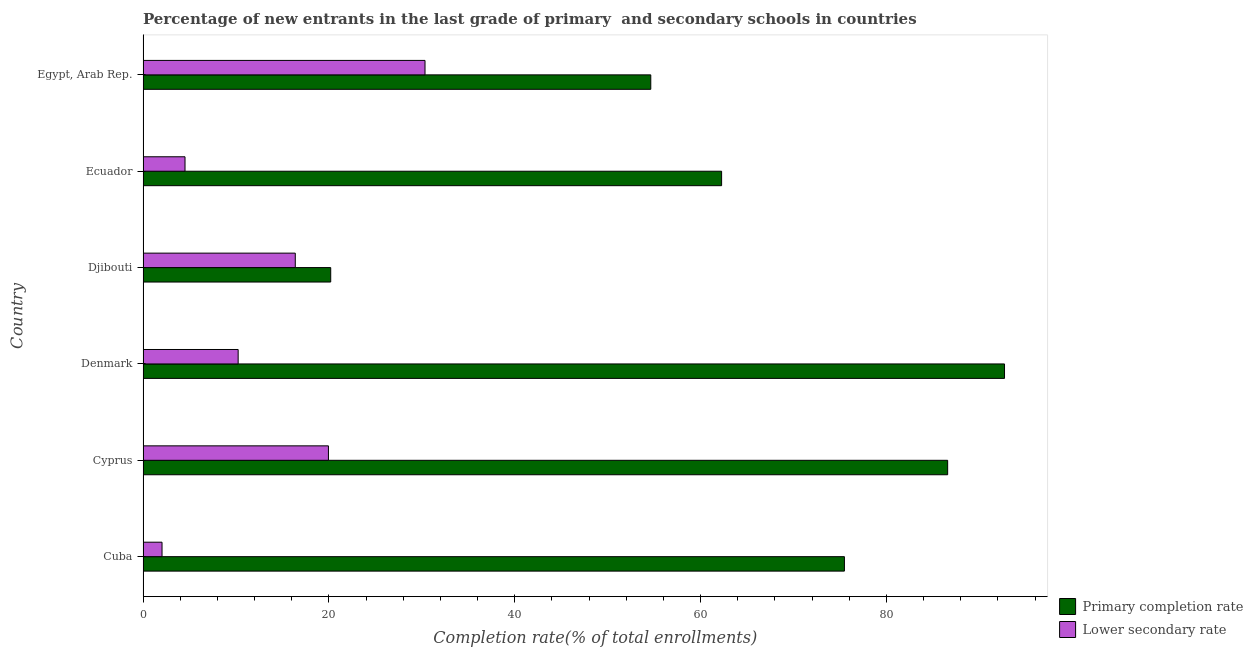How many different coloured bars are there?
Provide a succinct answer. 2. How many bars are there on the 5th tick from the top?
Keep it short and to the point. 2. What is the label of the 3rd group of bars from the top?
Offer a terse response. Djibouti. What is the completion rate in secondary schools in Egypt, Arab Rep.?
Provide a succinct answer. 30.35. Across all countries, what is the maximum completion rate in secondary schools?
Offer a terse response. 30.35. Across all countries, what is the minimum completion rate in primary schools?
Offer a very short reply. 20.2. In which country was the completion rate in primary schools minimum?
Ensure brevity in your answer.  Djibouti. What is the total completion rate in secondary schools in the graph?
Ensure brevity in your answer.  83.47. What is the difference between the completion rate in primary schools in Denmark and that in Egypt, Arab Rep.?
Give a very brief answer. 38.07. What is the difference between the completion rate in primary schools in Egypt, Arab Rep. and the completion rate in secondary schools in Cuba?
Provide a short and direct response. 52.6. What is the average completion rate in primary schools per country?
Offer a very short reply. 65.32. What is the difference between the completion rate in primary schools and completion rate in secondary schools in Djibouti?
Offer a very short reply. 3.81. In how many countries, is the completion rate in primary schools greater than 8 %?
Your answer should be compact. 6. What is the ratio of the completion rate in secondary schools in Djibouti to that in Ecuador?
Ensure brevity in your answer.  3.63. Is the completion rate in primary schools in Djibouti less than that in Egypt, Arab Rep.?
Your answer should be very brief. Yes. Is the difference between the completion rate in primary schools in Cuba and Egypt, Arab Rep. greater than the difference between the completion rate in secondary schools in Cuba and Egypt, Arab Rep.?
Ensure brevity in your answer.  Yes. What is the difference between the highest and the second highest completion rate in primary schools?
Provide a short and direct response. 6.12. What is the difference between the highest and the lowest completion rate in secondary schools?
Your response must be concise. 28.31. Is the sum of the completion rate in secondary schools in Cuba and Cyprus greater than the maximum completion rate in primary schools across all countries?
Your answer should be compact. No. What does the 2nd bar from the top in Ecuador represents?
Give a very brief answer. Primary completion rate. What does the 2nd bar from the bottom in Cuba represents?
Your answer should be very brief. Lower secondary rate. How many bars are there?
Ensure brevity in your answer.  12. Are all the bars in the graph horizontal?
Your response must be concise. Yes. How many countries are there in the graph?
Your answer should be very brief. 6. What is the difference between two consecutive major ticks on the X-axis?
Your answer should be compact. 20. Does the graph contain any zero values?
Your answer should be very brief. No. Where does the legend appear in the graph?
Provide a short and direct response. Bottom right. How many legend labels are there?
Keep it short and to the point. 2. What is the title of the graph?
Ensure brevity in your answer.  Percentage of new entrants in the last grade of primary  and secondary schools in countries. Does "Secondary Education" appear as one of the legend labels in the graph?
Provide a succinct answer. No. What is the label or title of the X-axis?
Provide a succinct answer. Completion rate(% of total enrollments). What is the Completion rate(% of total enrollments) in Primary completion rate in Cuba?
Offer a terse response. 75.49. What is the Completion rate(% of total enrollments) of Lower secondary rate in Cuba?
Make the answer very short. 2.04. What is the Completion rate(% of total enrollments) of Primary completion rate in Cyprus?
Provide a short and direct response. 86.6. What is the Completion rate(% of total enrollments) in Lower secondary rate in Cyprus?
Offer a terse response. 19.95. What is the Completion rate(% of total enrollments) of Primary completion rate in Denmark?
Ensure brevity in your answer.  92.72. What is the Completion rate(% of total enrollments) in Lower secondary rate in Denmark?
Offer a terse response. 10.24. What is the Completion rate(% of total enrollments) of Primary completion rate in Djibouti?
Provide a succinct answer. 20.2. What is the Completion rate(% of total enrollments) in Lower secondary rate in Djibouti?
Provide a succinct answer. 16.38. What is the Completion rate(% of total enrollments) of Primary completion rate in Ecuador?
Make the answer very short. 62.27. What is the Completion rate(% of total enrollments) in Lower secondary rate in Ecuador?
Make the answer very short. 4.52. What is the Completion rate(% of total enrollments) of Primary completion rate in Egypt, Arab Rep.?
Your response must be concise. 54.65. What is the Completion rate(% of total enrollments) of Lower secondary rate in Egypt, Arab Rep.?
Offer a very short reply. 30.35. Across all countries, what is the maximum Completion rate(% of total enrollments) of Primary completion rate?
Offer a very short reply. 92.72. Across all countries, what is the maximum Completion rate(% of total enrollments) of Lower secondary rate?
Your answer should be very brief. 30.35. Across all countries, what is the minimum Completion rate(% of total enrollments) in Primary completion rate?
Keep it short and to the point. 20.2. Across all countries, what is the minimum Completion rate(% of total enrollments) of Lower secondary rate?
Ensure brevity in your answer.  2.04. What is the total Completion rate(% of total enrollments) in Primary completion rate in the graph?
Your response must be concise. 391.91. What is the total Completion rate(% of total enrollments) of Lower secondary rate in the graph?
Offer a very short reply. 83.47. What is the difference between the Completion rate(% of total enrollments) of Primary completion rate in Cuba and that in Cyprus?
Your response must be concise. -11.11. What is the difference between the Completion rate(% of total enrollments) of Lower secondary rate in Cuba and that in Cyprus?
Give a very brief answer. -17.91. What is the difference between the Completion rate(% of total enrollments) of Primary completion rate in Cuba and that in Denmark?
Offer a very short reply. -17.23. What is the difference between the Completion rate(% of total enrollments) of Lower secondary rate in Cuba and that in Denmark?
Provide a succinct answer. -8.19. What is the difference between the Completion rate(% of total enrollments) of Primary completion rate in Cuba and that in Djibouti?
Keep it short and to the point. 55.29. What is the difference between the Completion rate(% of total enrollments) of Lower secondary rate in Cuba and that in Djibouti?
Your answer should be very brief. -14.34. What is the difference between the Completion rate(% of total enrollments) in Primary completion rate in Cuba and that in Ecuador?
Your answer should be very brief. 13.22. What is the difference between the Completion rate(% of total enrollments) of Lower secondary rate in Cuba and that in Ecuador?
Your answer should be very brief. -2.47. What is the difference between the Completion rate(% of total enrollments) of Primary completion rate in Cuba and that in Egypt, Arab Rep.?
Offer a terse response. 20.84. What is the difference between the Completion rate(% of total enrollments) of Lower secondary rate in Cuba and that in Egypt, Arab Rep.?
Your answer should be very brief. -28.31. What is the difference between the Completion rate(% of total enrollments) in Primary completion rate in Cyprus and that in Denmark?
Your answer should be very brief. -6.12. What is the difference between the Completion rate(% of total enrollments) in Lower secondary rate in Cyprus and that in Denmark?
Offer a very short reply. 9.72. What is the difference between the Completion rate(% of total enrollments) of Primary completion rate in Cyprus and that in Djibouti?
Offer a very short reply. 66.4. What is the difference between the Completion rate(% of total enrollments) in Lower secondary rate in Cyprus and that in Djibouti?
Provide a succinct answer. 3.57. What is the difference between the Completion rate(% of total enrollments) of Primary completion rate in Cyprus and that in Ecuador?
Ensure brevity in your answer.  24.33. What is the difference between the Completion rate(% of total enrollments) of Lower secondary rate in Cyprus and that in Ecuador?
Your answer should be compact. 15.44. What is the difference between the Completion rate(% of total enrollments) of Primary completion rate in Cyprus and that in Egypt, Arab Rep.?
Provide a succinct answer. 31.95. What is the difference between the Completion rate(% of total enrollments) of Lower secondary rate in Cyprus and that in Egypt, Arab Rep.?
Give a very brief answer. -10.39. What is the difference between the Completion rate(% of total enrollments) in Primary completion rate in Denmark and that in Djibouti?
Offer a very short reply. 72.52. What is the difference between the Completion rate(% of total enrollments) in Lower secondary rate in Denmark and that in Djibouti?
Provide a short and direct response. -6.15. What is the difference between the Completion rate(% of total enrollments) of Primary completion rate in Denmark and that in Ecuador?
Keep it short and to the point. 30.45. What is the difference between the Completion rate(% of total enrollments) of Lower secondary rate in Denmark and that in Ecuador?
Make the answer very short. 5.72. What is the difference between the Completion rate(% of total enrollments) in Primary completion rate in Denmark and that in Egypt, Arab Rep.?
Your answer should be compact. 38.07. What is the difference between the Completion rate(% of total enrollments) of Lower secondary rate in Denmark and that in Egypt, Arab Rep.?
Your response must be concise. -20.11. What is the difference between the Completion rate(% of total enrollments) in Primary completion rate in Djibouti and that in Ecuador?
Make the answer very short. -42.07. What is the difference between the Completion rate(% of total enrollments) of Lower secondary rate in Djibouti and that in Ecuador?
Offer a very short reply. 11.87. What is the difference between the Completion rate(% of total enrollments) in Primary completion rate in Djibouti and that in Egypt, Arab Rep.?
Keep it short and to the point. -34.45. What is the difference between the Completion rate(% of total enrollments) in Lower secondary rate in Djibouti and that in Egypt, Arab Rep.?
Offer a terse response. -13.96. What is the difference between the Completion rate(% of total enrollments) in Primary completion rate in Ecuador and that in Egypt, Arab Rep.?
Offer a terse response. 7.62. What is the difference between the Completion rate(% of total enrollments) in Lower secondary rate in Ecuador and that in Egypt, Arab Rep.?
Your answer should be very brief. -25.83. What is the difference between the Completion rate(% of total enrollments) in Primary completion rate in Cuba and the Completion rate(% of total enrollments) in Lower secondary rate in Cyprus?
Provide a succinct answer. 55.54. What is the difference between the Completion rate(% of total enrollments) of Primary completion rate in Cuba and the Completion rate(% of total enrollments) of Lower secondary rate in Denmark?
Your answer should be very brief. 65.25. What is the difference between the Completion rate(% of total enrollments) in Primary completion rate in Cuba and the Completion rate(% of total enrollments) in Lower secondary rate in Djibouti?
Provide a short and direct response. 59.1. What is the difference between the Completion rate(% of total enrollments) of Primary completion rate in Cuba and the Completion rate(% of total enrollments) of Lower secondary rate in Ecuador?
Your answer should be compact. 70.97. What is the difference between the Completion rate(% of total enrollments) of Primary completion rate in Cuba and the Completion rate(% of total enrollments) of Lower secondary rate in Egypt, Arab Rep.?
Make the answer very short. 45.14. What is the difference between the Completion rate(% of total enrollments) in Primary completion rate in Cyprus and the Completion rate(% of total enrollments) in Lower secondary rate in Denmark?
Make the answer very short. 76.36. What is the difference between the Completion rate(% of total enrollments) of Primary completion rate in Cyprus and the Completion rate(% of total enrollments) of Lower secondary rate in Djibouti?
Your answer should be very brief. 70.22. What is the difference between the Completion rate(% of total enrollments) of Primary completion rate in Cyprus and the Completion rate(% of total enrollments) of Lower secondary rate in Ecuador?
Provide a short and direct response. 82.08. What is the difference between the Completion rate(% of total enrollments) of Primary completion rate in Cyprus and the Completion rate(% of total enrollments) of Lower secondary rate in Egypt, Arab Rep.?
Offer a very short reply. 56.25. What is the difference between the Completion rate(% of total enrollments) in Primary completion rate in Denmark and the Completion rate(% of total enrollments) in Lower secondary rate in Djibouti?
Provide a short and direct response. 76.34. What is the difference between the Completion rate(% of total enrollments) of Primary completion rate in Denmark and the Completion rate(% of total enrollments) of Lower secondary rate in Ecuador?
Offer a very short reply. 88.2. What is the difference between the Completion rate(% of total enrollments) in Primary completion rate in Denmark and the Completion rate(% of total enrollments) in Lower secondary rate in Egypt, Arab Rep.?
Ensure brevity in your answer.  62.37. What is the difference between the Completion rate(% of total enrollments) of Primary completion rate in Djibouti and the Completion rate(% of total enrollments) of Lower secondary rate in Ecuador?
Give a very brief answer. 15.68. What is the difference between the Completion rate(% of total enrollments) in Primary completion rate in Djibouti and the Completion rate(% of total enrollments) in Lower secondary rate in Egypt, Arab Rep.?
Give a very brief answer. -10.15. What is the difference between the Completion rate(% of total enrollments) of Primary completion rate in Ecuador and the Completion rate(% of total enrollments) of Lower secondary rate in Egypt, Arab Rep.?
Offer a terse response. 31.92. What is the average Completion rate(% of total enrollments) of Primary completion rate per country?
Provide a short and direct response. 65.32. What is the average Completion rate(% of total enrollments) in Lower secondary rate per country?
Offer a terse response. 13.91. What is the difference between the Completion rate(% of total enrollments) of Primary completion rate and Completion rate(% of total enrollments) of Lower secondary rate in Cuba?
Give a very brief answer. 73.45. What is the difference between the Completion rate(% of total enrollments) of Primary completion rate and Completion rate(% of total enrollments) of Lower secondary rate in Cyprus?
Keep it short and to the point. 66.65. What is the difference between the Completion rate(% of total enrollments) of Primary completion rate and Completion rate(% of total enrollments) of Lower secondary rate in Denmark?
Your answer should be compact. 82.48. What is the difference between the Completion rate(% of total enrollments) of Primary completion rate and Completion rate(% of total enrollments) of Lower secondary rate in Djibouti?
Offer a very short reply. 3.81. What is the difference between the Completion rate(% of total enrollments) in Primary completion rate and Completion rate(% of total enrollments) in Lower secondary rate in Ecuador?
Offer a very short reply. 57.75. What is the difference between the Completion rate(% of total enrollments) in Primary completion rate and Completion rate(% of total enrollments) in Lower secondary rate in Egypt, Arab Rep.?
Give a very brief answer. 24.3. What is the ratio of the Completion rate(% of total enrollments) of Primary completion rate in Cuba to that in Cyprus?
Offer a very short reply. 0.87. What is the ratio of the Completion rate(% of total enrollments) in Lower secondary rate in Cuba to that in Cyprus?
Offer a very short reply. 0.1. What is the ratio of the Completion rate(% of total enrollments) in Primary completion rate in Cuba to that in Denmark?
Give a very brief answer. 0.81. What is the ratio of the Completion rate(% of total enrollments) in Lower secondary rate in Cuba to that in Denmark?
Keep it short and to the point. 0.2. What is the ratio of the Completion rate(% of total enrollments) of Primary completion rate in Cuba to that in Djibouti?
Offer a very short reply. 3.74. What is the ratio of the Completion rate(% of total enrollments) in Lower secondary rate in Cuba to that in Djibouti?
Your answer should be compact. 0.12. What is the ratio of the Completion rate(% of total enrollments) of Primary completion rate in Cuba to that in Ecuador?
Make the answer very short. 1.21. What is the ratio of the Completion rate(% of total enrollments) in Lower secondary rate in Cuba to that in Ecuador?
Give a very brief answer. 0.45. What is the ratio of the Completion rate(% of total enrollments) in Primary completion rate in Cuba to that in Egypt, Arab Rep.?
Give a very brief answer. 1.38. What is the ratio of the Completion rate(% of total enrollments) in Lower secondary rate in Cuba to that in Egypt, Arab Rep.?
Offer a terse response. 0.07. What is the ratio of the Completion rate(% of total enrollments) of Primary completion rate in Cyprus to that in Denmark?
Provide a short and direct response. 0.93. What is the ratio of the Completion rate(% of total enrollments) in Lower secondary rate in Cyprus to that in Denmark?
Give a very brief answer. 1.95. What is the ratio of the Completion rate(% of total enrollments) in Primary completion rate in Cyprus to that in Djibouti?
Keep it short and to the point. 4.29. What is the ratio of the Completion rate(% of total enrollments) in Lower secondary rate in Cyprus to that in Djibouti?
Offer a terse response. 1.22. What is the ratio of the Completion rate(% of total enrollments) of Primary completion rate in Cyprus to that in Ecuador?
Your response must be concise. 1.39. What is the ratio of the Completion rate(% of total enrollments) of Lower secondary rate in Cyprus to that in Ecuador?
Offer a very short reply. 4.42. What is the ratio of the Completion rate(% of total enrollments) of Primary completion rate in Cyprus to that in Egypt, Arab Rep.?
Offer a very short reply. 1.58. What is the ratio of the Completion rate(% of total enrollments) in Lower secondary rate in Cyprus to that in Egypt, Arab Rep.?
Provide a succinct answer. 0.66. What is the ratio of the Completion rate(% of total enrollments) of Primary completion rate in Denmark to that in Djibouti?
Your response must be concise. 4.59. What is the ratio of the Completion rate(% of total enrollments) of Lower secondary rate in Denmark to that in Djibouti?
Make the answer very short. 0.62. What is the ratio of the Completion rate(% of total enrollments) in Primary completion rate in Denmark to that in Ecuador?
Ensure brevity in your answer.  1.49. What is the ratio of the Completion rate(% of total enrollments) in Lower secondary rate in Denmark to that in Ecuador?
Your answer should be compact. 2.27. What is the ratio of the Completion rate(% of total enrollments) of Primary completion rate in Denmark to that in Egypt, Arab Rep.?
Offer a very short reply. 1.7. What is the ratio of the Completion rate(% of total enrollments) in Lower secondary rate in Denmark to that in Egypt, Arab Rep.?
Make the answer very short. 0.34. What is the ratio of the Completion rate(% of total enrollments) of Primary completion rate in Djibouti to that in Ecuador?
Make the answer very short. 0.32. What is the ratio of the Completion rate(% of total enrollments) in Lower secondary rate in Djibouti to that in Ecuador?
Provide a short and direct response. 3.63. What is the ratio of the Completion rate(% of total enrollments) in Primary completion rate in Djibouti to that in Egypt, Arab Rep.?
Give a very brief answer. 0.37. What is the ratio of the Completion rate(% of total enrollments) in Lower secondary rate in Djibouti to that in Egypt, Arab Rep.?
Provide a succinct answer. 0.54. What is the ratio of the Completion rate(% of total enrollments) in Primary completion rate in Ecuador to that in Egypt, Arab Rep.?
Your answer should be compact. 1.14. What is the ratio of the Completion rate(% of total enrollments) in Lower secondary rate in Ecuador to that in Egypt, Arab Rep.?
Make the answer very short. 0.15. What is the difference between the highest and the second highest Completion rate(% of total enrollments) in Primary completion rate?
Offer a very short reply. 6.12. What is the difference between the highest and the second highest Completion rate(% of total enrollments) in Lower secondary rate?
Your answer should be very brief. 10.39. What is the difference between the highest and the lowest Completion rate(% of total enrollments) in Primary completion rate?
Your answer should be compact. 72.52. What is the difference between the highest and the lowest Completion rate(% of total enrollments) in Lower secondary rate?
Provide a short and direct response. 28.31. 